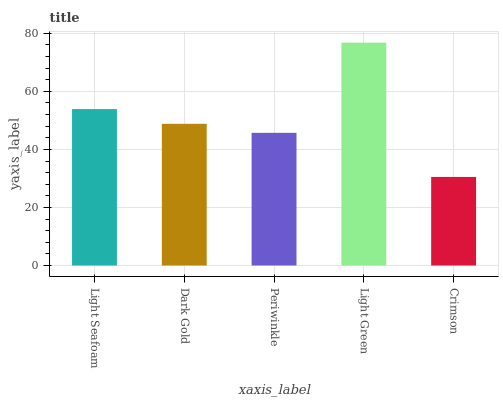Is Crimson the minimum?
Answer yes or no. Yes. Is Light Green the maximum?
Answer yes or no. Yes. Is Dark Gold the minimum?
Answer yes or no. No. Is Dark Gold the maximum?
Answer yes or no. No. Is Light Seafoam greater than Dark Gold?
Answer yes or no. Yes. Is Dark Gold less than Light Seafoam?
Answer yes or no. Yes. Is Dark Gold greater than Light Seafoam?
Answer yes or no. No. Is Light Seafoam less than Dark Gold?
Answer yes or no. No. Is Dark Gold the high median?
Answer yes or no. Yes. Is Dark Gold the low median?
Answer yes or no. Yes. Is Light Green the high median?
Answer yes or no. No. Is Periwinkle the low median?
Answer yes or no. No. 